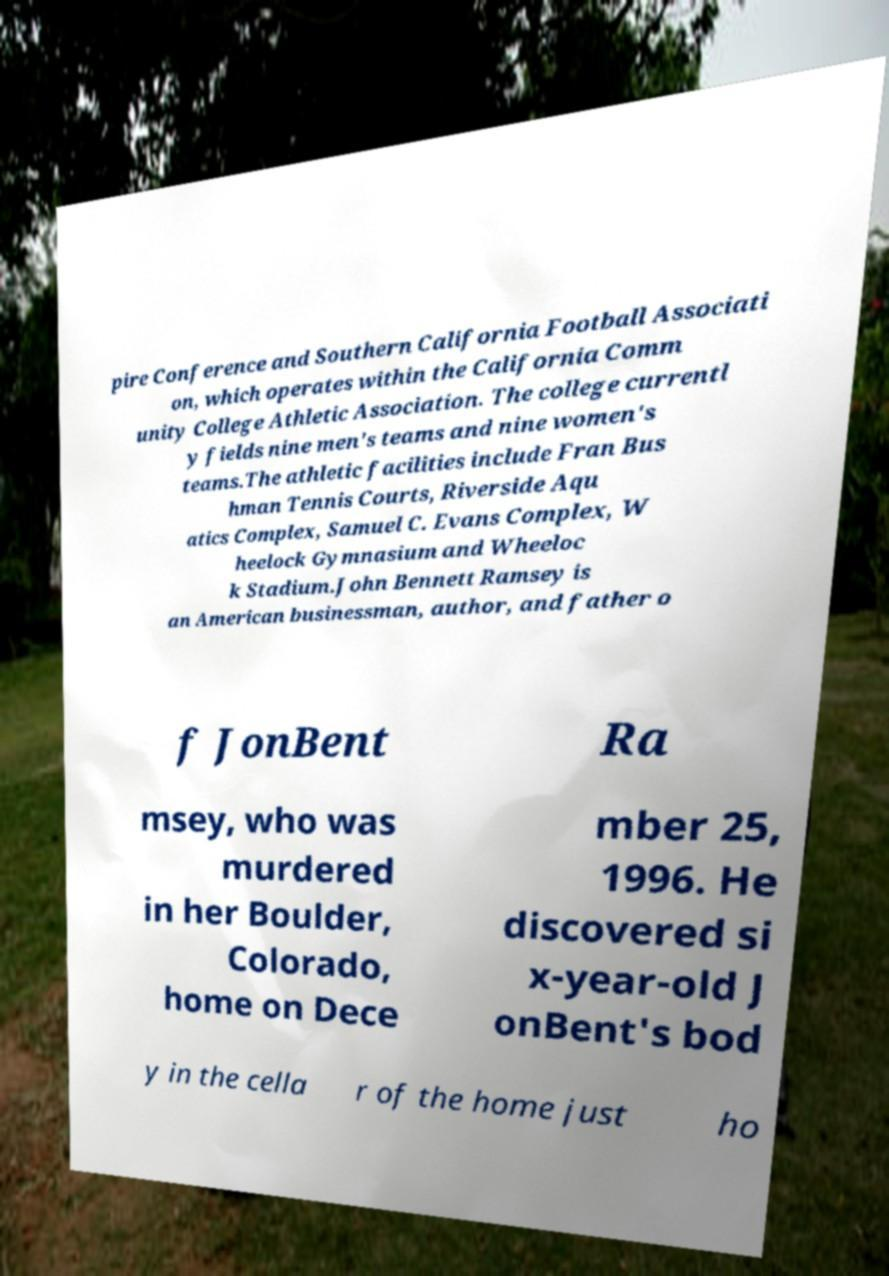Could you assist in decoding the text presented in this image and type it out clearly? pire Conference and Southern California Football Associati on, which operates within the California Comm unity College Athletic Association. The college currentl y fields nine men's teams and nine women's teams.The athletic facilities include Fran Bus hman Tennis Courts, Riverside Aqu atics Complex, Samuel C. Evans Complex, W heelock Gymnasium and Wheeloc k Stadium.John Bennett Ramsey is an American businessman, author, and father o f JonBent Ra msey, who was murdered in her Boulder, Colorado, home on Dece mber 25, 1996. He discovered si x-year-old J onBent's bod y in the cella r of the home just ho 